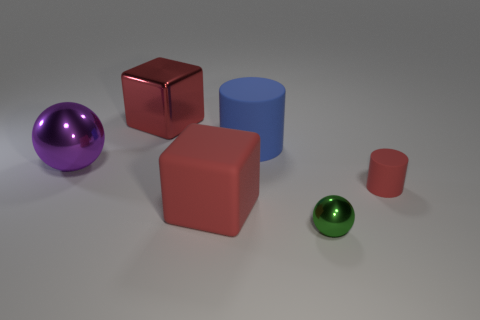There is a thing that is behind the purple object and on the left side of the big blue cylinder; what shape is it?
Your answer should be compact. Cube. How many purple objects are either large metal things or cylinders?
Ensure brevity in your answer.  1. Does the red thing that is on the right side of the large cylinder have the same size as the cube to the right of the big red shiny thing?
Offer a very short reply. No. How many things are either large red things or big blue rubber cylinders?
Your answer should be compact. 3. Are there any other objects that have the same shape as the blue matte object?
Your answer should be very brief. Yes. Is the number of big red blocks less than the number of large blue matte cylinders?
Provide a short and direct response. No. Is the shape of the blue thing the same as the tiny red matte object?
Give a very brief answer. Yes. What number of objects are either tiny gray rubber balls or big metal blocks behind the blue cylinder?
Your answer should be very brief. 1. How many large gray cylinders are there?
Ensure brevity in your answer.  0. Are there any gray matte cubes of the same size as the green metallic object?
Your answer should be very brief. No. 